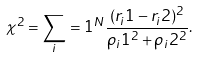Convert formula to latex. <formula><loc_0><loc_0><loc_500><loc_500>\chi ^ { 2 } = \sum _ { i } = 1 ^ { N } \frac { ( r _ { i } 1 - r _ { i } 2 ) ^ { 2 } } { \rho _ { i } 1 ^ { 2 } + \rho _ { i } 2 ^ { 2 } } .</formula> 